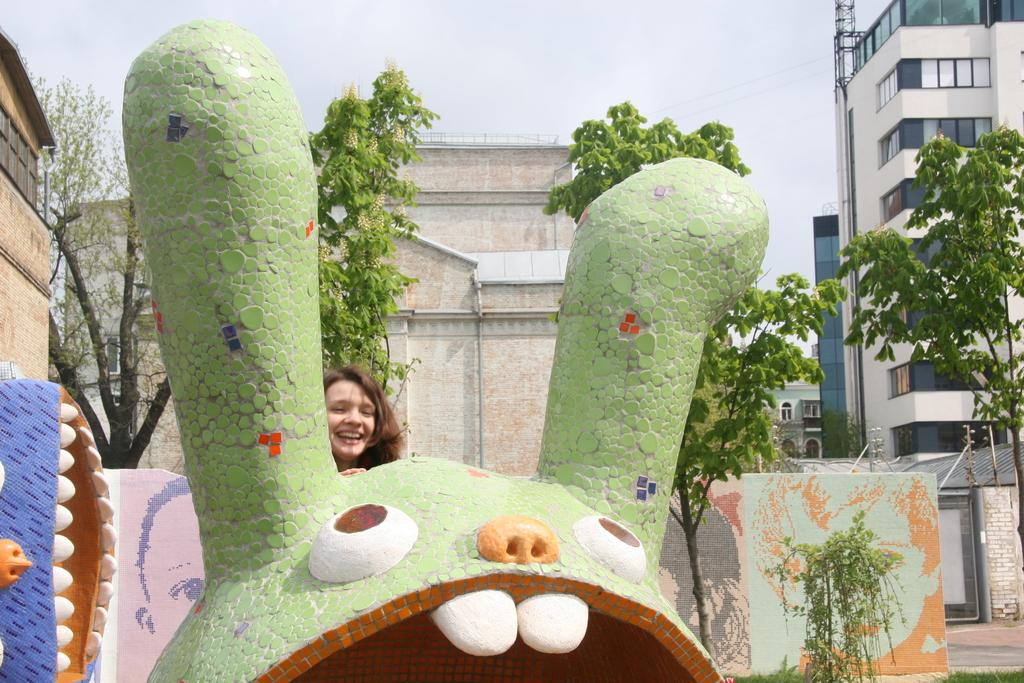What type of structures can be seen in the image? There are buildings in the image. What type of vegetation is present in the image? There are trees in the image. What part of the natural environment is visible in the image? The sky is visible in the image. Who or what is present in the image? There are women in the image. What type of fork can be seen in the image? There is no fork present in the image. What type of rail is visible in the image? There is no rail present in the image. What type of grape is being eaten by the women in the image? There is no grape present in the image. 